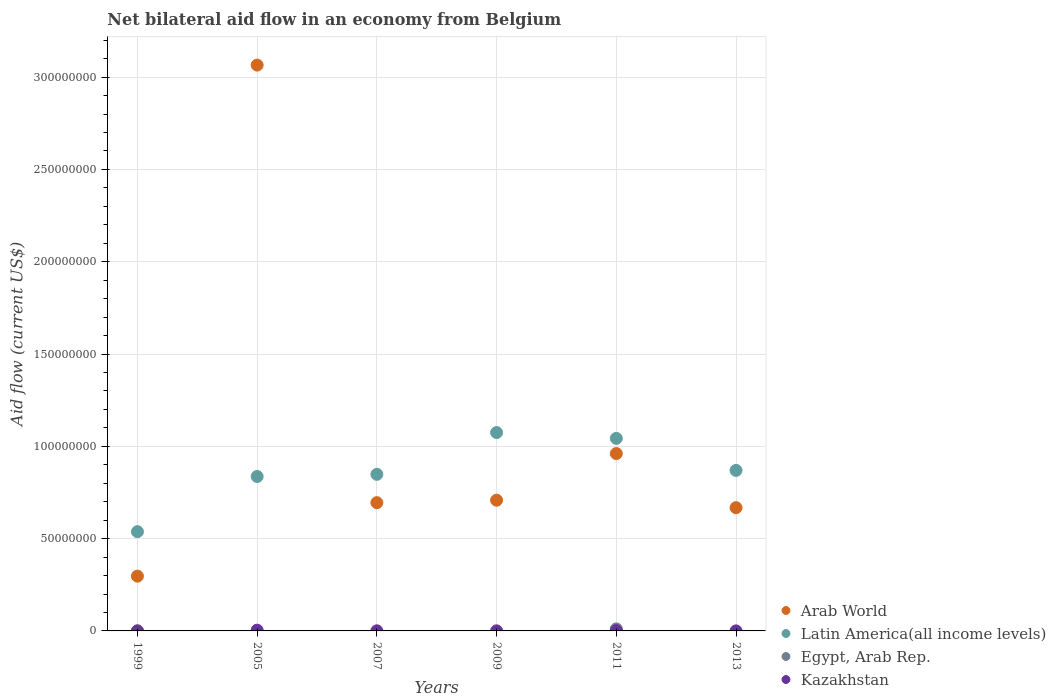How many different coloured dotlines are there?
Give a very brief answer. 4. What is the net bilateral aid flow in Egypt, Arab Rep. in 2009?
Provide a short and direct response. 0. Across all years, what is the maximum net bilateral aid flow in Arab World?
Give a very brief answer. 3.07e+08. Across all years, what is the minimum net bilateral aid flow in Arab World?
Offer a terse response. 2.97e+07. In which year was the net bilateral aid flow in Latin America(all income levels) maximum?
Provide a short and direct response. 2009. What is the total net bilateral aid flow in Egypt, Arab Rep. in the graph?
Your answer should be compact. 1.12e+06. What is the difference between the net bilateral aid flow in Latin America(all income levels) in 1999 and that in 2011?
Provide a short and direct response. -5.05e+07. What is the difference between the net bilateral aid flow in Arab World in 2011 and the net bilateral aid flow in Kazakhstan in 2009?
Make the answer very short. 9.60e+07. What is the average net bilateral aid flow in Kazakhstan per year?
Provide a short and direct response. 1.17e+05. In the year 2013, what is the difference between the net bilateral aid flow in Kazakhstan and net bilateral aid flow in Arab World?
Give a very brief answer. -6.68e+07. In how many years, is the net bilateral aid flow in Egypt, Arab Rep. greater than 260000000 US$?
Your response must be concise. 0. What is the ratio of the net bilateral aid flow in Kazakhstan in 2005 to that in 2007?
Make the answer very short. 6.83. Is the net bilateral aid flow in Kazakhstan in 2005 less than that in 2011?
Your response must be concise. No. Is the difference between the net bilateral aid flow in Kazakhstan in 2009 and 2013 greater than the difference between the net bilateral aid flow in Arab World in 2009 and 2013?
Give a very brief answer. No. What is the difference between the highest and the lowest net bilateral aid flow in Egypt, Arab Rep.?
Your answer should be compact. 1.10e+06. Is it the case that in every year, the sum of the net bilateral aid flow in Egypt, Arab Rep. and net bilateral aid flow in Arab World  is greater than the sum of net bilateral aid flow in Latin America(all income levels) and net bilateral aid flow in Kazakhstan?
Give a very brief answer. No. Is the net bilateral aid flow in Arab World strictly greater than the net bilateral aid flow in Egypt, Arab Rep. over the years?
Give a very brief answer. Yes. How many dotlines are there?
Your response must be concise. 4. What is the difference between two consecutive major ticks on the Y-axis?
Keep it short and to the point. 5.00e+07. Are the values on the major ticks of Y-axis written in scientific E-notation?
Keep it short and to the point. No. Does the graph contain any zero values?
Make the answer very short. Yes. Does the graph contain grids?
Offer a terse response. Yes. How many legend labels are there?
Ensure brevity in your answer.  4. What is the title of the graph?
Provide a short and direct response. Net bilateral aid flow in an economy from Belgium. What is the label or title of the Y-axis?
Your response must be concise. Aid flow (current US$). What is the Aid flow (current US$) in Arab World in 1999?
Your answer should be very brief. 2.97e+07. What is the Aid flow (current US$) of Latin America(all income levels) in 1999?
Ensure brevity in your answer.  5.38e+07. What is the Aid flow (current US$) of Arab World in 2005?
Keep it short and to the point. 3.07e+08. What is the Aid flow (current US$) of Latin America(all income levels) in 2005?
Give a very brief answer. 8.37e+07. What is the Aid flow (current US$) of Egypt, Arab Rep. in 2005?
Your answer should be compact. 0. What is the Aid flow (current US$) in Arab World in 2007?
Provide a short and direct response. 6.95e+07. What is the Aid flow (current US$) of Latin America(all income levels) in 2007?
Your response must be concise. 8.48e+07. What is the Aid flow (current US$) of Egypt, Arab Rep. in 2007?
Provide a short and direct response. 0. What is the Aid flow (current US$) in Kazakhstan in 2007?
Your answer should be very brief. 6.00e+04. What is the Aid flow (current US$) in Arab World in 2009?
Make the answer very short. 7.08e+07. What is the Aid flow (current US$) in Latin America(all income levels) in 2009?
Your answer should be compact. 1.07e+08. What is the Aid flow (current US$) of Egypt, Arab Rep. in 2009?
Ensure brevity in your answer.  0. What is the Aid flow (current US$) in Arab World in 2011?
Your answer should be compact. 9.61e+07. What is the Aid flow (current US$) in Latin America(all income levels) in 2011?
Make the answer very short. 1.04e+08. What is the Aid flow (current US$) in Egypt, Arab Rep. in 2011?
Ensure brevity in your answer.  1.10e+06. What is the Aid flow (current US$) of Arab World in 2013?
Give a very brief answer. 6.68e+07. What is the Aid flow (current US$) in Latin America(all income levels) in 2013?
Offer a very short reply. 8.70e+07. What is the Aid flow (current US$) in Egypt, Arab Rep. in 2013?
Make the answer very short. 0. What is the Aid flow (current US$) of Kazakhstan in 2013?
Offer a terse response. 10000. Across all years, what is the maximum Aid flow (current US$) of Arab World?
Your response must be concise. 3.07e+08. Across all years, what is the maximum Aid flow (current US$) of Latin America(all income levels)?
Your answer should be very brief. 1.07e+08. Across all years, what is the maximum Aid flow (current US$) in Egypt, Arab Rep.?
Your answer should be very brief. 1.10e+06. Across all years, what is the maximum Aid flow (current US$) of Kazakhstan?
Offer a very short reply. 4.10e+05. Across all years, what is the minimum Aid flow (current US$) of Arab World?
Offer a very short reply. 2.97e+07. Across all years, what is the minimum Aid flow (current US$) of Latin America(all income levels)?
Your answer should be compact. 5.38e+07. Across all years, what is the minimum Aid flow (current US$) in Egypt, Arab Rep.?
Your response must be concise. 0. Across all years, what is the minimum Aid flow (current US$) in Kazakhstan?
Ensure brevity in your answer.  10000. What is the total Aid flow (current US$) of Arab World in the graph?
Keep it short and to the point. 6.39e+08. What is the total Aid flow (current US$) in Latin America(all income levels) in the graph?
Keep it short and to the point. 5.21e+08. What is the total Aid flow (current US$) in Egypt, Arab Rep. in the graph?
Give a very brief answer. 1.12e+06. What is the difference between the Aid flow (current US$) in Arab World in 1999 and that in 2005?
Offer a terse response. -2.77e+08. What is the difference between the Aid flow (current US$) of Latin America(all income levels) in 1999 and that in 2005?
Keep it short and to the point. -2.99e+07. What is the difference between the Aid flow (current US$) of Kazakhstan in 1999 and that in 2005?
Provide a short and direct response. -4.00e+05. What is the difference between the Aid flow (current US$) of Arab World in 1999 and that in 2007?
Provide a short and direct response. -3.98e+07. What is the difference between the Aid flow (current US$) of Latin America(all income levels) in 1999 and that in 2007?
Your answer should be compact. -3.11e+07. What is the difference between the Aid flow (current US$) in Arab World in 1999 and that in 2009?
Make the answer very short. -4.12e+07. What is the difference between the Aid flow (current US$) of Latin America(all income levels) in 1999 and that in 2009?
Give a very brief answer. -5.37e+07. What is the difference between the Aid flow (current US$) of Arab World in 1999 and that in 2011?
Ensure brevity in your answer.  -6.64e+07. What is the difference between the Aid flow (current US$) of Latin America(all income levels) in 1999 and that in 2011?
Your answer should be compact. -5.05e+07. What is the difference between the Aid flow (current US$) in Egypt, Arab Rep. in 1999 and that in 2011?
Keep it short and to the point. -1.08e+06. What is the difference between the Aid flow (current US$) of Kazakhstan in 1999 and that in 2011?
Your answer should be very brief. -1.50e+05. What is the difference between the Aid flow (current US$) in Arab World in 1999 and that in 2013?
Offer a very short reply. -3.71e+07. What is the difference between the Aid flow (current US$) in Latin America(all income levels) in 1999 and that in 2013?
Your response must be concise. -3.32e+07. What is the difference between the Aid flow (current US$) of Kazakhstan in 1999 and that in 2013?
Keep it short and to the point. 0. What is the difference between the Aid flow (current US$) of Arab World in 2005 and that in 2007?
Your answer should be very brief. 2.37e+08. What is the difference between the Aid flow (current US$) of Latin America(all income levels) in 2005 and that in 2007?
Offer a terse response. -1.17e+06. What is the difference between the Aid flow (current US$) in Arab World in 2005 and that in 2009?
Make the answer very short. 2.36e+08. What is the difference between the Aid flow (current US$) of Latin America(all income levels) in 2005 and that in 2009?
Provide a succinct answer. -2.38e+07. What is the difference between the Aid flow (current US$) in Kazakhstan in 2005 and that in 2009?
Give a very brief answer. 3.60e+05. What is the difference between the Aid flow (current US$) of Arab World in 2005 and that in 2011?
Keep it short and to the point. 2.10e+08. What is the difference between the Aid flow (current US$) in Latin America(all income levels) in 2005 and that in 2011?
Offer a very short reply. -2.06e+07. What is the difference between the Aid flow (current US$) of Arab World in 2005 and that in 2013?
Your answer should be compact. 2.40e+08. What is the difference between the Aid flow (current US$) of Latin America(all income levels) in 2005 and that in 2013?
Ensure brevity in your answer.  -3.30e+06. What is the difference between the Aid flow (current US$) in Kazakhstan in 2005 and that in 2013?
Provide a short and direct response. 4.00e+05. What is the difference between the Aid flow (current US$) in Arab World in 2007 and that in 2009?
Your answer should be very brief. -1.34e+06. What is the difference between the Aid flow (current US$) in Latin America(all income levels) in 2007 and that in 2009?
Keep it short and to the point. -2.26e+07. What is the difference between the Aid flow (current US$) in Arab World in 2007 and that in 2011?
Your answer should be compact. -2.66e+07. What is the difference between the Aid flow (current US$) of Latin America(all income levels) in 2007 and that in 2011?
Ensure brevity in your answer.  -1.95e+07. What is the difference between the Aid flow (current US$) in Arab World in 2007 and that in 2013?
Offer a very short reply. 2.71e+06. What is the difference between the Aid flow (current US$) of Latin America(all income levels) in 2007 and that in 2013?
Make the answer very short. -2.13e+06. What is the difference between the Aid flow (current US$) of Arab World in 2009 and that in 2011?
Ensure brevity in your answer.  -2.53e+07. What is the difference between the Aid flow (current US$) in Latin America(all income levels) in 2009 and that in 2011?
Provide a short and direct response. 3.16e+06. What is the difference between the Aid flow (current US$) of Kazakhstan in 2009 and that in 2011?
Offer a very short reply. -1.10e+05. What is the difference between the Aid flow (current US$) in Arab World in 2009 and that in 2013?
Your answer should be very brief. 4.05e+06. What is the difference between the Aid flow (current US$) of Latin America(all income levels) in 2009 and that in 2013?
Make the answer very short. 2.05e+07. What is the difference between the Aid flow (current US$) in Kazakhstan in 2009 and that in 2013?
Your response must be concise. 4.00e+04. What is the difference between the Aid flow (current US$) of Arab World in 2011 and that in 2013?
Keep it short and to the point. 2.93e+07. What is the difference between the Aid flow (current US$) in Latin America(all income levels) in 2011 and that in 2013?
Ensure brevity in your answer.  1.74e+07. What is the difference between the Aid flow (current US$) of Arab World in 1999 and the Aid flow (current US$) of Latin America(all income levels) in 2005?
Provide a succinct answer. -5.40e+07. What is the difference between the Aid flow (current US$) in Arab World in 1999 and the Aid flow (current US$) in Kazakhstan in 2005?
Offer a very short reply. 2.93e+07. What is the difference between the Aid flow (current US$) in Latin America(all income levels) in 1999 and the Aid flow (current US$) in Kazakhstan in 2005?
Your response must be concise. 5.34e+07. What is the difference between the Aid flow (current US$) in Egypt, Arab Rep. in 1999 and the Aid flow (current US$) in Kazakhstan in 2005?
Keep it short and to the point. -3.90e+05. What is the difference between the Aid flow (current US$) of Arab World in 1999 and the Aid flow (current US$) of Latin America(all income levels) in 2007?
Keep it short and to the point. -5.52e+07. What is the difference between the Aid flow (current US$) of Arab World in 1999 and the Aid flow (current US$) of Kazakhstan in 2007?
Offer a terse response. 2.96e+07. What is the difference between the Aid flow (current US$) of Latin America(all income levels) in 1999 and the Aid flow (current US$) of Kazakhstan in 2007?
Keep it short and to the point. 5.37e+07. What is the difference between the Aid flow (current US$) in Egypt, Arab Rep. in 1999 and the Aid flow (current US$) in Kazakhstan in 2007?
Your answer should be very brief. -4.00e+04. What is the difference between the Aid flow (current US$) in Arab World in 1999 and the Aid flow (current US$) in Latin America(all income levels) in 2009?
Provide a short and direct response. -7.78e+07. What is the difference between the Aid flow (current US$) in Arab World in 1999 and the Aid flow (current US$) in Kazakhstan in 2009?
Give a very brief answer. 2.96e+07. What is the difference between the Aid flow (current US$) in Latin America(all income levels) in 1999 and the Aid flow (current US$) in Kazakhstan in 2009?
Make the answer very short. 5.37e+07. What is the difference between the Aid flow (current US$) of Arab World in 1999 and the Aid flow (current US$) of Latin America(all income levels) in 2011?
Give a very brief answer. -7.46e+07. What is the difference between the Aid flow (current US$) of Arab World in 1999 and the Aid flow (current US$) of Egypt, Arab Rep. in 2011?
Offer a terse response. 2.86e+07. What is the difference between the Aid flow (current US$) of Arab World in 1999 and the Aid flow (current US$) of Kazakhstan in 2011?
Give a very brief answer. 2.95e+07. What is the difference between the Aid flow (current US$) in Latin America(all income levels) in 1999 and the Aid flow (current US$) in Egypt, Arab Rep. in 2011?
Offer a very short reply. 5.27e+07. What is the difference between the Aid flow (current US$) in Latin America(all income levels) in 1999 and the Aid flow (current US$) in Kazakhstan in 2011?
Your response must be concise. 5.36e+07. What is the difference between the Aid flow (current US$) of Arab World in 1999 and the Aid flow (current US$) of Latin America(all income levels) in 2013?
Your answer should be very brief. -5.73e+07. What is the difference between the Aid flow (current US$) of Arab World in 1999 and the Aid flow (current US$) of Kazakhstan in 2013?
Your answer should be compact. 2.97e+07. What is the difference between the Aid flow (current US$) in Latin America(all income levels) in 1999 and the Aid flow (current US$) in Kazakhstan in 2013?
Give a very brief answer. 5.38e+07. What is the difference between the Aid flow (current US$) of Arab World in 2005 and the Aid flow (current US$) of Latin America(all income levels) in 2007?
Provide a short and direct response. 2.22e+08. What is the difference between the Aid flow (current US$) of Arab World in 2005 and the Aid flow (current US$) of Kazakhstan in 2007?
Offer a very short reply. 3.06e+08. What is the difference between the Aid flow (current US$) in Latin America(all income levels) in 2005 and the Aid flow (current US$) in Kazakhstan in 2007?
Your answer should be compact. 8.36e+07. What is the difference between the Aid flow (current US$) in Arab World in 2005 and the Aid flow (current US$) in Latin America(all income levels) in 2009?
Provide a succinct answer. 1.99e+08. What is the difference between the Aid flow (current US$) in Arab World in 2005 and the Aid flow (current US$) in Kazakhstan in 2009?
Your response must be concise. 3.06e+08. What is the difference between the Aid flow (current US$) in Latin America(all income levels) in 2005 and the Aid flow (current US$) in Kazakhstan in 2009?
Give a very brief answer. 8.36e+07. What is the difference between the Aid flow (current US$) of Arab World in 2005 and the Aid flow (current US$) of Latin America(all income levels) in 2011?
Keep it short and to the point. 2.02e+08. What is the difference between the Aid flow (current US$) in Arab World in 2005 and the Aid flow (current US$) in Egypt, Arab Rep. in 2011?
Your answer should be very brief. 3.05e+08. What is the difference between the Aid flow (current US$) in Arab World in 2005 and the Aid flow (current US$) in Kazakhstan in 2011?
Provide a short and direct response. 3.06e+08. What is the difference between the Aid flow (current US$) in Latin America(all income levels) in 2005 and the Aid flow (current US$) in Egypt, Arab Rep. in 2011?
Provide a short and direct response. 8.26e+07. What is the difference between the Aid flow (current US$) of Latin America(all income levels) in 2005 and the Aid flow (current US$) of Kazakhstan in 2011?
Ensure brevity in your answer.  8.35e+07. What is the difference between the Aid flow (current US$) of Arab World in 2005 and the Aid flow (current US$) of Latin America(all income levels) in 2013?
Provide a succinct answer. 2.20e+08. What is the difference between the Aid flow (current US$) in Arab World in 2005 and the Aid flow (current US$) in Kazakhstan in 2013?
Ensure brevity in your answer.  3.07e+08. What is the difference between the Aid flow (current US$) in Latin America(all income levels) in 2005 and the Aid flow (current US$) in Kazakhstan in 2013?
Your response must be concise. 8.36e+07. What is the difference between the Aid flow (current US$) in Arab World in 2007 and the Aid flow (current US$) in Latin America(all income levels) in 2009?
Offer a terse response. -3.80e+07. What is the difference between the Aid flow (current US$) of Arab World in 2007 and the Aid flow (current US$) of Kazakhstan in 2009?
Your answer should be compact. 6.94e+07. What is the difference between the Aid flow (current US$) in Latin America(all income levels) in 2007 and the Aid flow (current US$) in Kazakhstan in 2009?
Give a very brief answer. 8.48e+07. What is the difference between the Aid flow (current US$) of Arab World in 2007 and the Aid flow (current US$) of Latin America(all income levels) in 2011?
Give a very brief answer. -3.48e+07. What is the difference between the Aid flow (current US$) in Arab World in 2007 and the Aid flow (current US$) in Egypt, Arab Rep. in 2011?
Keep it short and to the point. 6.84e+07. What is the difference between the Aid flow (current US$) in Arab World in 2007 and the Aid flow (current US$) in Kazakhstan in 2011?
Provide a short and direct response. 6.93e+07. What is the difference between the Aid flow (current US$) in Latin America(all income levels) in 2007 and the Aid flow (current US$) in Egypt, Arab Rep. in 2011?
Give a very brief answer. 8.37e+07. What is the difference between the Aid flow (current US$) of Latin America(all income levels) in 2007 and the Aid flow (current US$) of Kazakhstan in 2011?
Provide a short and direct response. 8.47e+07. What is the difference between the Aid flow (current US$) of Arab World in 2007 and the Aid flow (current US$) of Latin America(all income levels) in 2013?
Provide a short and direct response. -1.75e+07. What is the difference between the Aid flow (current US$) of Arab World in 2007 and the Aid flow (current US$) of Kazakhstan in 2013?
Your answer should be very brief. 6.95e+07. What is the difference between the Aid flow (current US$) in Latin America(all income levels) in 2007 and the Aid flow (current US$) in Kazakhstan in 2013?
Offer a very short reply. 8.48e+07. What is the difference between the Aid flow (current US$) of Arab World in 2009 and the Aid flow (current US$) of Latin America(all income levels) in 2011?
Offer a terse response. -3.35e+07. What is the difference between the Aid flow (current US$) in Arab World in 2009 and the Aid flow (current US$) in Egypt, Arab Rep. in 2011?
Your answer should be compact. 6.97e+07. What is the difference between the Aid flow (current US$) in Arab World in 2009 and the Aid flow (current US$) in Kazakhstan in 2011?
Offer a very short reply. 7.07e+07. What is the difference between the Aid flow (current US$) of Latin America(all income levels) in 2009 and the Aid flow (current US$) of Egypt, Arab Rep. in 2011?
Offer a very short reply. 1.06e+08. What is the difference between the Aid flow (current US$) of Latin America(all income levels) in 2009 and the Aid flow (current US$) of Kazakhstan in 2011?
Your response must be concise. 1.07e+08. What is the difference between the Aid flow (current US$) in Arab World in 2009 and the Aid flow (current US$) in Latin America(all income levels) in 2013?
Your response must be concise. -1.61e+07. What is the difference between the Aid flow (current US$) in Arab World in 2009 and the Aid flow (current US$) in Kazakhstan in 2013?
Offer a very short reply. 7.08e+07. What is the difference between the Aid flow (current US$) in Latin America(all income levels) in 2009 and the Aid flow (current US$) in Kazakhstan in 2013?
Provide a succinct answer. 1.07e+08. What is the difference between the Aid flow (current US$) of Arab World in 2011 and the Aid flow (current US$) of Latin America(all income levels) in 2013?
Offer a very short reply. 9.12e+06. What is the difference between the Aid flow (current US$) of Arab World in 2011 and the Aid flow (current US$) of Kazakhstan in 2013?
Give a very brief answer. 9.61e+07. What is the difference between the Aid flow (current US$) in Latin America(all income levels) in 2011 and the Aid flow (current US$) in Kazakhstan in 2013?
Ensure brevity in your answer.  1.04e+08. What is the difference between the Aid flow (current US$) of Egypt, Arab Rep. in 2011 and the Aid flow (current US$) of Kazakhstan in 2013?
Ensure brevity in your answer.  1.09e+06. What is the average Aid flow (current US$) of Arab World per year?
Keep it short and to the point. 1.07e+08. What is the average Aid flow (current US$) of Latin America(all income levels) per year?
Give a very brief answer. 8.68e+07. What is the average Aid flow (current US$) in Egypt, Arab Rep. per year?
Provide a succinct answer. 1.87e+05. What is the average Aid flow (current US$) in Kazakhstan per year?
Provide a succinct answer. 1.17e+05. In the year 1999, what is the difference between the Aid flow (current US$) in Arab World and Aid flow (current US$) in Latin America(all income levels)?
Keep it short and to the point. -2.41e+07. In the year 1999, what is the difference between the Aid flow (current US$) in Arab World and Aid flow (current US$) in Egypt, Arab Rep.?
Your response must be concise. 2.96e+07. In the year 1999, what is the difference between the Aid flow (current US$) in Arab World and Aid flow (current US$) in Kazakhstan?
Give a very brief answer. 2.97e+07. In the year 1999, what is the difference between the Aid flow (current US$) of Latin America(all income levels) and Aid flow (current US$) of Egypt, Arab Rep.?
Give a very brief answer. 5.38e+07. In the year 1999, what is the difference between the Aid flow (current US$) in Latin America(all income levels) and Aid flow (current US$) in Kazakhstan?
Give a very brief answer. 5.38e+07. In the year 2005, what is the difference between the Aid flow (current US$) of Arab World and Aid flow (current US$) of Latin America(all income levels)?
Ensure brevity in your answer.  2.23e+08. In the year 2005, what is the difference between the Aid flow (current US$) in Arab World and Aid flow (current US$) in Kazakhstan?
Give a very brief answer. 3.06e+08. In the year 2005, what is the difference between the Aid flow (current US$) of Latin America(all income levels) and Aid flow (current US$) of Kazakhstan?
Provide a succinct answer. 8.32e+07. In the year 2007, what is the difference between the Aid flow (current US$) in Arab World and Aid flow (current US$) in Latin America(all income levels)?
Your response must be concise. -1.54e+07. In the year 2007, what is the difference between the Aid flow (current US$) in Arab World and Aid flow (current US$) in Kazakhstan?
Provide a short and direct response. 6.94e+07. In the year 2007, what is the difference between the Aid flow (current US$) in Latin America(all income levels) and Aid flow (current US$) in Kazakhstan?
Offer a very short reply. 8.48e+07. In the year 2009, what is the difference between the Aid flow (current US$) in Arab World and Aid flow (current US$) in Latin America(all income levels)?
Make the answer very short. -3.66e+07. In the year 2009, what is the difference between the Aid flow (current US$) of Arab World and Aid flow (current US$) of Kazakhstan?
Provide a short and direct response. 7.08e+07. In the year 2009, what is the difference between the Aid flow (current US$) in Latin America(all income levels) and Aid flow (current US$) in Kazakhstan?
Your response must be concise. 1.07e+08. In the year 2011, what is the difference between the Aid flow (current US$) of Arab World and Aid flow (current US$) of Latin America(all income levels)?
Ensure brevity in your answer.  -8.23e+06. In the year 2011, what is the difference between the Aid flow (current US$) of Arab World and Aid flow (current US$) of Egypt, Arab Rep.?
Provide a short and direct response. 9.50e+07. In the year 2011, what is the difference between the Aid flow (current US$) in Arab World and Aid flow (current US$) in Kazakhstan?
Make the answer very short. 9.59e+07. In the year 2011, what is the difference between the Aid flow (current US$) in Latin America(all income levels) and Aid flow (current US$) in Egypt, Arab Rep.?
Keep it short and to the point. 1.03e+08. In the year 2011, what is the difference between the Aid flow (current US$) in Latin America(all income levels) and Aid flow (current US$) in Kazakhstan?
Ensure brevity in your answer.  1.04e+08. In the year 2011, what is the difference between the Aid flow (current US$) of Egypt, Arab Rep. and Aid flow (current US$) of Kazakhstan?
Your response must be concise. 9.40e+05. In the year 2013, what is the difference between the Aid flow (current US$) in Arab World and Aid flow (current US$) in Latin America(all income levels)?
Offer a very short reply. -2.02e+07. In the year 2013, what is the difference between the Aid flow (current US$) of Arab World and Aid flow (current US$) of Kazakhstan?
Ensure brevity in your answer.  6.68e+07. In the year 2013, what is the difference between the Aid flow (current US$) of Latin America(all income levels) and Aid flow (current US$) of Kazakhstan?
Your response must be concise. 8.70e+07. What is the ratio of the Aid flow (current US$) in Arab World in 1999 to that in 2005?
Keep it short and to the point. 0.1. What is the ratio of the Aid flow (current US$) of Latin America(all income levels) in 1999 to that in 2005?
Give a very brief answer. 0.64. What is the ratio of the Aid flow (current US$) in Kazakhstan in 1999 to that in 2005?
Give a very brief answer. 0.02. What is the ratio of the Aid flow (current US$) of Arab World in 1999 to that in 2007?
Ensure brevity in your answer.  0.43. What is the ratio of the Aid flow (current US$) of Latin America(all income levels) in 1999 to that in 2007?
Ensure brevity in your answer.  0.63. What is the ratio of the Aid flow (current US$) in Arab World in 1999 to that in 2009?
Make the answer very short. 0.42. What is the ratio of the Aid flow (current US$) of Latin America(all income levels) in 1999 to that in 2009?
Give a very brief answer. 0.5. What is the ratio of the Aid flow (current US$) in Kazakhstan in 1999 to that in 2009?
Provide a short and direct response. 0.2. What is the ratio of the Aid flow (current US$) of Arab World in 1999 to that in 2011?
Your response must be concise. 0.31. What is the ratio of the Aid flow (current US$) of Latin America(all income levels) in 1999 to that in 2011?
Keep it short and to the point. 0.52. What is the ratio of the Aid flow (current US$) in Egypt, Arab Rep. in 1999 to that in 2011?
Your answer should be very brief. 0.02. What is the ratio of the Aid flow (current US$) of Kazakhstan in 1999 to that in 2011?
Offer a very short reply. 0.06. What is the ratio of the Aid flow (current US$) in Arab World in 1999 to that in 2013?
Keep it short and to the point. 0.44. What is the ratio of the Aid flow (current US$) in Latin America(all income levels) in 1999 to that in 2013?
Ensure brevity in your answer.  0.62. What is the ratio of the Aid flow (current US$) of Kazakhstan in 1999 to that in 2013?
Ensure brevity in your answer.  1. What is the ratio of the Aid flow (current US$) of Arab World in 2005 to that in 2007?
Your answer should be very brief. 4.41. What is the ratio of the Aid flow (current US$) in Latin America(all income levels) in 2005 to that in 2007?
Your answer should be compact. 0.99. What is the ratio of the Aid flow (current US$) in Kazakhstan in 2005 to that in 2007?
Offer a very short reply. 6.83. What is the ratio of the Aid flow (current US$) of Arab World in 2005 to that in 2009?
Ensure brevity in your answer.  4.33. What is the ratio of the Aid flow (current US$) in Latin America(all income levels) in 2005 to that in 2009?
Give a very brief answer. 0.78. What is the ratio of the Aid flow (current US$) of Kazakhstan in 2005 to that in 2009?
Offer a very short reply. 8.2. What is the ratio of the Aid flow (current US$) of Arab World in 2005 to that in 2011?
Offer a very short reply. 3.19. What is the ratio of the Aid flow (current US$) in Latin America(all income levels) in 2005 to that in 2011?
Offer a very short reply. 0.8. What is the ratio of the Aid flow (current US$) of Kazakhstan in 2005 to that in 2011?
Your response must be concise. 2.56. What is the ratio of the Aid flow (current US$) of Arab World in 2005 to that in 2013?
Provide a succinct answer. 4.59. What is the ratio of the Aid flow (current US$) of Latin America(all income levels) in 2005 to that in 2013?
Your response must be concise. 0.96. What is the ratio of the Aid flow (current US$) of Kazakhstan in 2005 to that in 2013?
Provide a short and direct response. 41. What is the ratio of the Aid flow (current US$) of Arab World in 2007 to that in 2009?
Your response must be concise. 0.98. What is the ratio of the Aid flow (current US$) of Latin America(all income levels) in 2007 to that in 2009?
Provide a succinct answer. 0.79. What is the ratio of the Aid flow (current US$) in Kazakhstan in 2007 to that in 2009?
Your answer should be very brief. 1.2. What is the ratio of the Aid flow (current US$) of Arab World in 2007 to that in 2011?
Give a very brief answer. 0.72. What is the ratio of the Aid flow (current US$) of Latin America(all income levels) in 2007 to that in 2011?
Ensure brevity in your answer.  0.81. What is the ratio of the Aid flow (current US$) of Kazakhstan in 2007 to that in 2011?
Offer a very short reply. 0.38. What is the ratio of the Aid flow (current US$) of Arab World in 2007 to that in 2013?
Provide a short and direct response. 1.04. What is the ratio of the Aid flow (current US$) of Latin America(all income levels) in 2007 to that in 2013?
Offer a very short reply. 0.98. What is the ratio of the Aid flow (current US$) of Kazakhstan in 2007 to that in 2013?
Provide a short and direct response. 6. What is the ratio of the Aid flow (current US$) of Arab World in 2009 to that in 2011?
Offer a very short reply. 0.74. What is the ratio of the Aid flow (current US$) of Latin America(all income levels) in 2009 to that in 2011?
Your answer should be very brief. 1.03. What is the ratio of the Aid flow (current US$) in Kazakhstan in 2009 to that in 2011?
Your response must be concise. 0.31. What is the ratio of the Aid flow (current US$) of Arab World in 2009 to that in 2013?
Your answer should be compact. 1.06. What is the ratio of the Aid flow (current US$) in Latin America(all income levels) in 2009 to that in 2013?
Ensure brevity in your answer.  1.24. What is the ratio of the Aid flow (current US$) of Kazakhstan in 2009 to that in 2013?
Your answer should be very brief. 5. What is the ratio of the Aid flow (current US$) in Arab World in 2011 to that in 2013?
Keep it short and to the point. 1.44. What is the ratio of the Aid flow (current US$) of Latin America(all income levels) in 2011 to that in 2013?
Provide a short and direct response. 1.2. What is the difference between the highest and the second highest Aid flow (current US$) in Arab World?
Provide a short and direct response. 2.10e+08. What is the difference between the highest and the second highest Aid flow (current US$) in Latin America(all income levels)?
Offer a terse response. 3.16e+06. What is the difference between the highest and the second highest Aid flow (current US$) in Kazakhstan?
Your answer should be compact. 2.50e+05. What is the difference between the highest and the lowest Aid flow (current US$) of Arab World?
Offer a terse response. 2.77e+08. What is the difference between the highest and the lowest Aid flow (current US$) in Latin America(all income levels)?
Your answer should be compact. 5.37e+07. What is the difference between the highest and the lowest Aid flow (current US$) in Egypt, Arab Rep.?
Your answer should be very brief. 1.10e+06. What is the difference between the highest and the lowest Aid flow (current US$) of Kazakhstan?
Your answer should be compact. 4.00e+05. 